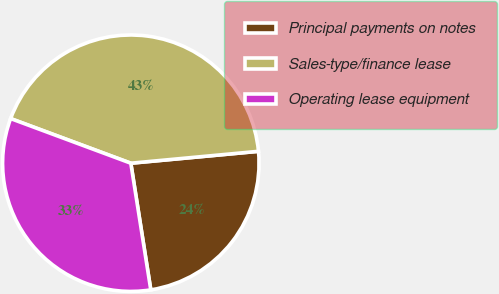<chart> <loc_0><loc_0><loc_500><loc_500><pie_chart><fcel>Principal payments on notes<fcel>Sales-type/finance lease<fcel>Operating lease equipment<nl><fcel>23.99%<fcel>42.86%<fcel>33.15%<nl></chart> 